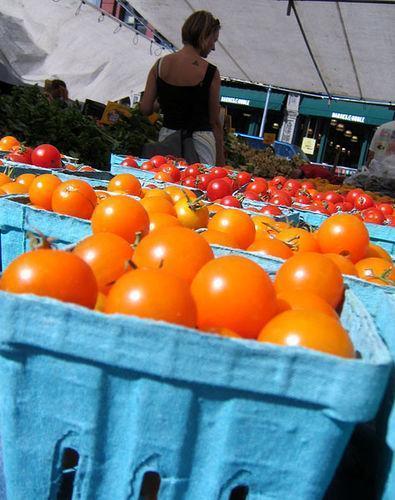How many oranges can you see?
Give a very brief answer. 6. How many clocks do you see?
Give a very brief answer. 0. 